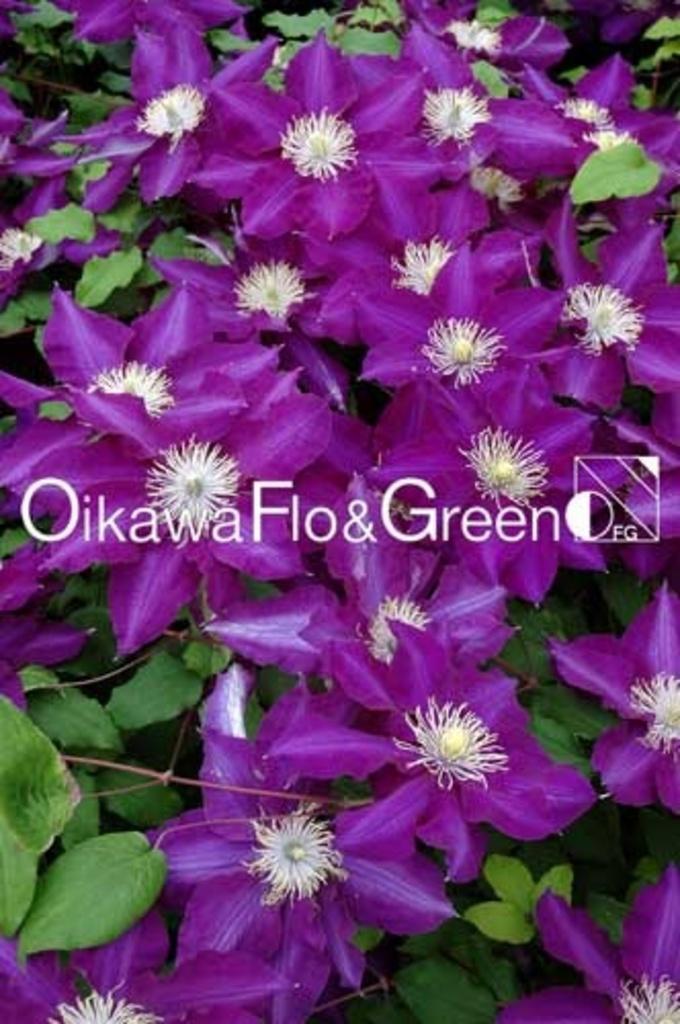Please provide a concise description of this image. In this picture we can see flowers and leaves and on the image there is a watermark. 